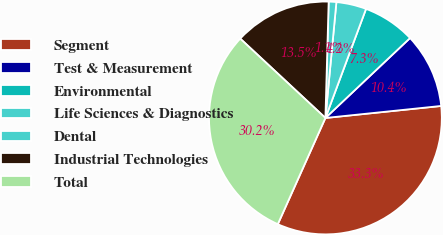Convert chart. <chart><loc_0><loc_0><loc_500><loc_500><pie_chart><fcel>Segment<fcel>Test & Measurement<fcel>Environmental<fcel>Life Sciences & Diagnostics<fcel>Dental<fcel>Industrial Technologies<fcel>Total<nl><fcel>33.35%<fcel>10.4%<fcel>7.28%<fcel>4.17%<fcel>1.06%<fcel>13.51%<fcel>30.23%<nl></chart> 